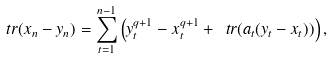Convert formula to latex. <formula><loc_0><loc_0><loc_500><loc_500>\ t r ( x _ { n } - y _ { n } ) = \sum _ { t = 1 } ^ { n - 1 } \left ( y _ { t } ^ { q + 1 } - x _ { t } ^ { q + 1 } + \ t r ( a _ { t } ( y _ { t } - x _ { t } ) ) \right ) ,</formula> 